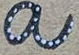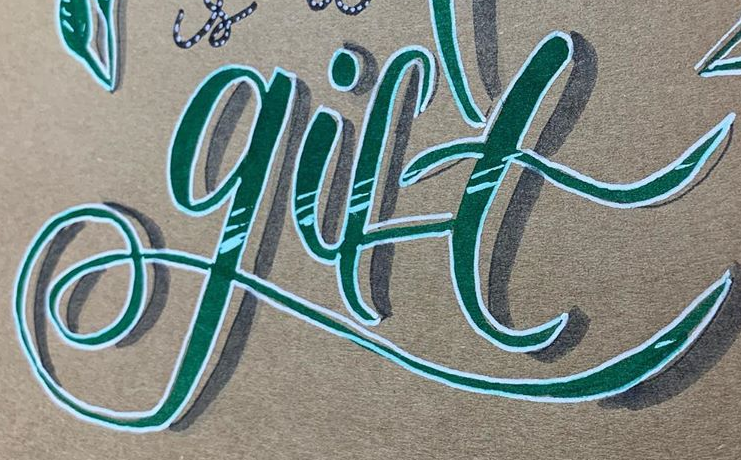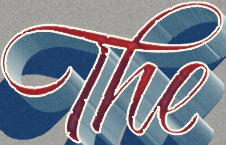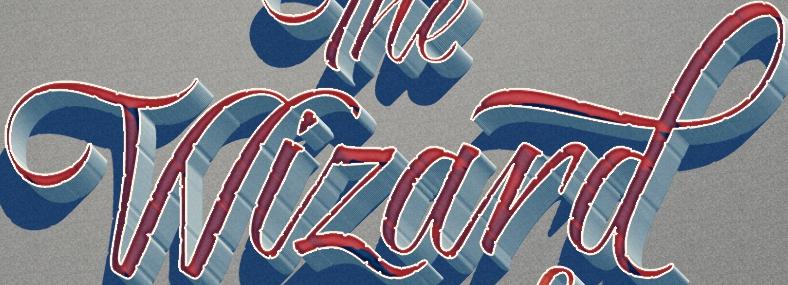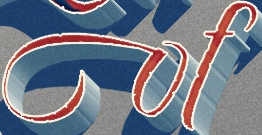What text appears in these images from left to right, separated by a semicolon? a; gift; The; Wizard; of 